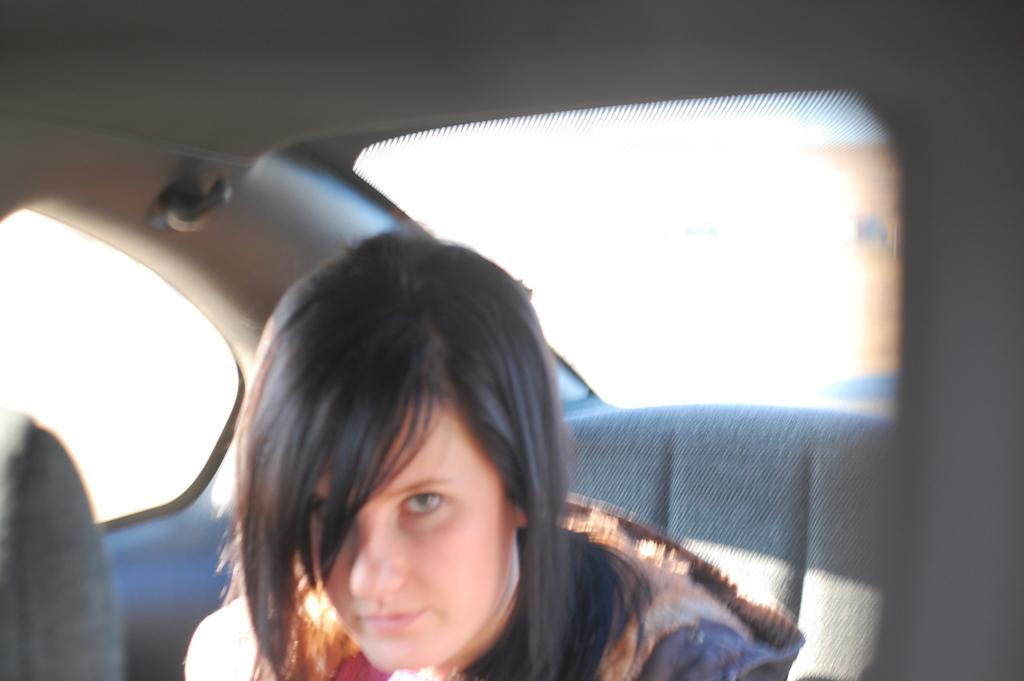What is the main subject of the image? The main subject of the image is a vehicle. How much of the vehicle can be seen in the image? The vehicle appears to be partially visible or "truncated" in the image. Is there anyone inside the vehicle? Yes, there is a person sitting inside the vehicle. What color is the background of the image? The background of the image is white in color. How many legs can be seen kicking in the image? There are no legs visible in the image, let alone any kicking motion. 